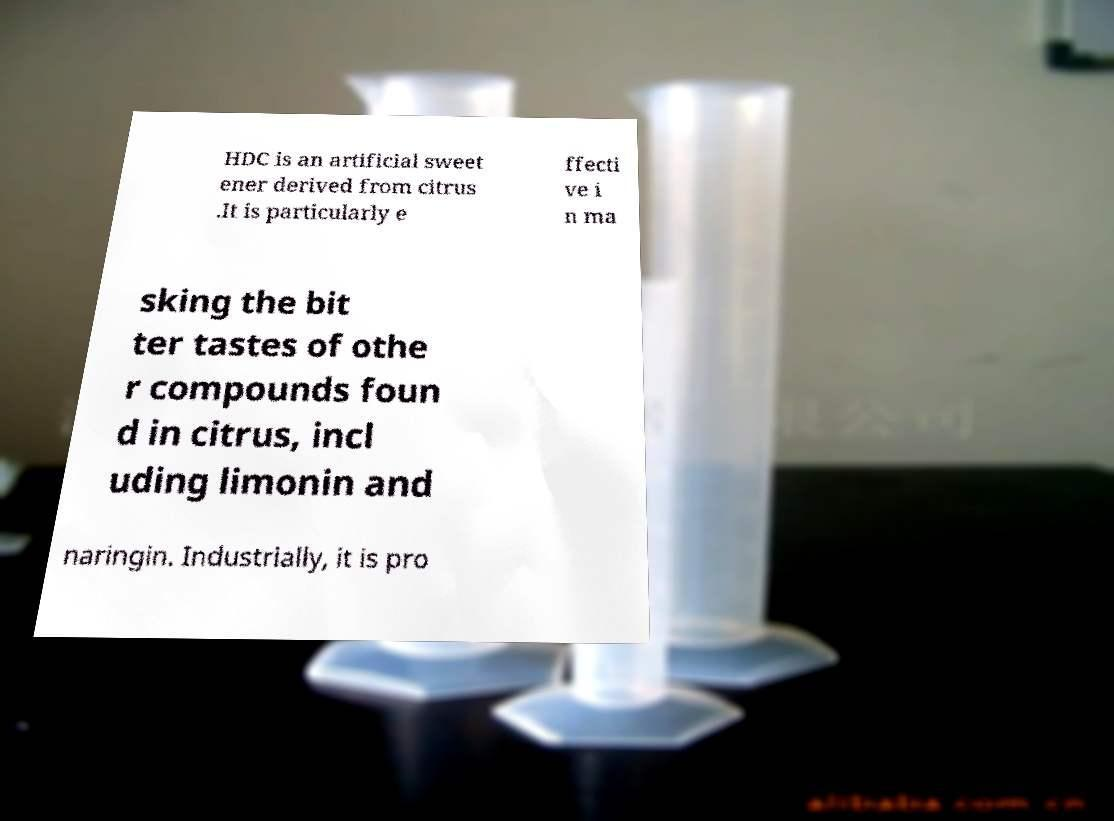Could you extract and type out the text from this image? HDC is an artificial sweet ener derived from citrus .It is particularly e ffecti ve i n ma sking the bit ter tastes of othe r compounds foun d in citrus, incl uding limonin and naringin. Industrially, it is pro 